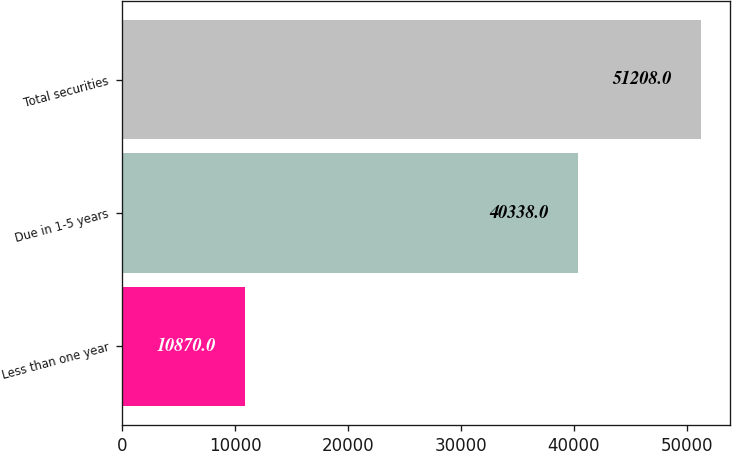Convert chart. <chart><loc_0><loc_0><loc_500><loc_500><bar_chart><fcel>Less than one year<fcel>Due in 1-5 years<fcel>Total securities<nl><fcel>10870<fcel>40338<fcel>51208<nl></chart> 